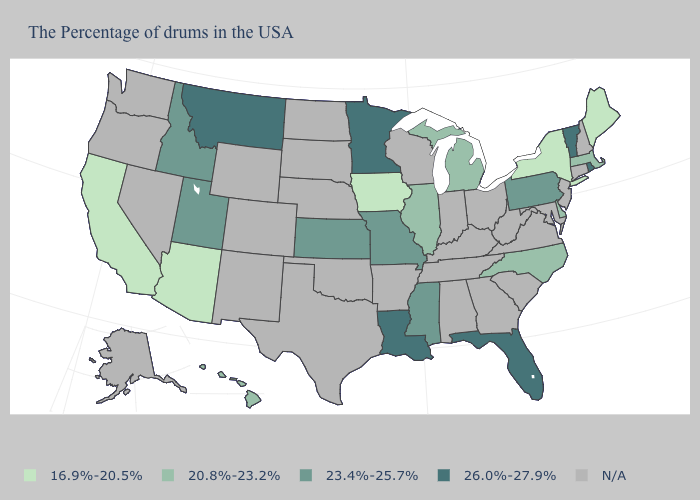Among the states that border Vermont , does Massachusetts have the highest value?
Write a very short answer. Yes. Among the states that border Connecticut , which have the highest value?
Give a very brief answer. Rhode Island. Name the states that have a value in the range N/A?
Be succinct. New Hampshire, Connecticut, New Jersey, Maryland, Virginia, South Carolina, West Virginia, Ohio, Georgia, Kentucky, Indiana, Alabama, Tennessee, Wisconsin, Arkansas, Nebraska, Oklahoma, Texas, South Dakota, North Dakota, Wyoming, Colorado, New Mexico, Nevada, Washington, Oregon, Alaska. Is the legend a continuous bar?
Give a very brief answer. No. Which states have the highest value in the USA?
Quick response, please. Rhode Island, Vermont, Florida, Louisiana, Minnesota, Montana. Name the states that have a value in the range 20.8%-23.2%?
Answer briefly. Massachusetts, Delaware, North Carolina, Michigan, Illinois, Hawaii. Does Arizona have the lowest value in the USA?
Short answer required. Yes. Does Arizona have the lowest value in the West?
Quick response, please. Yes. Name the states that have a value in the range 26.0%-27.9%?
Give a very brief answer. Rhode Island, Vermont, Florida, Louisiana, Minnesota, Montana. What is the highest value in the South ?
Give a very brief answer. 26.0%-27.9%. Name the states that have a value in the range 20.8%-23.2%?
Answer briefly. Massachusetts, Delaware, North Carolina, Michigan, Illinois, Hawaii. What is the value of Kentucky?
Concise answer only. N/A. What is the value of Rhode Island?
Answer briefly. 26.0%-27.9%. Name the states that have a value in the range 20.8%-23.2%?
Short answer required. Massachusetts, Delaware, North Carolina, Michigan, Illinois, Hawaii. 